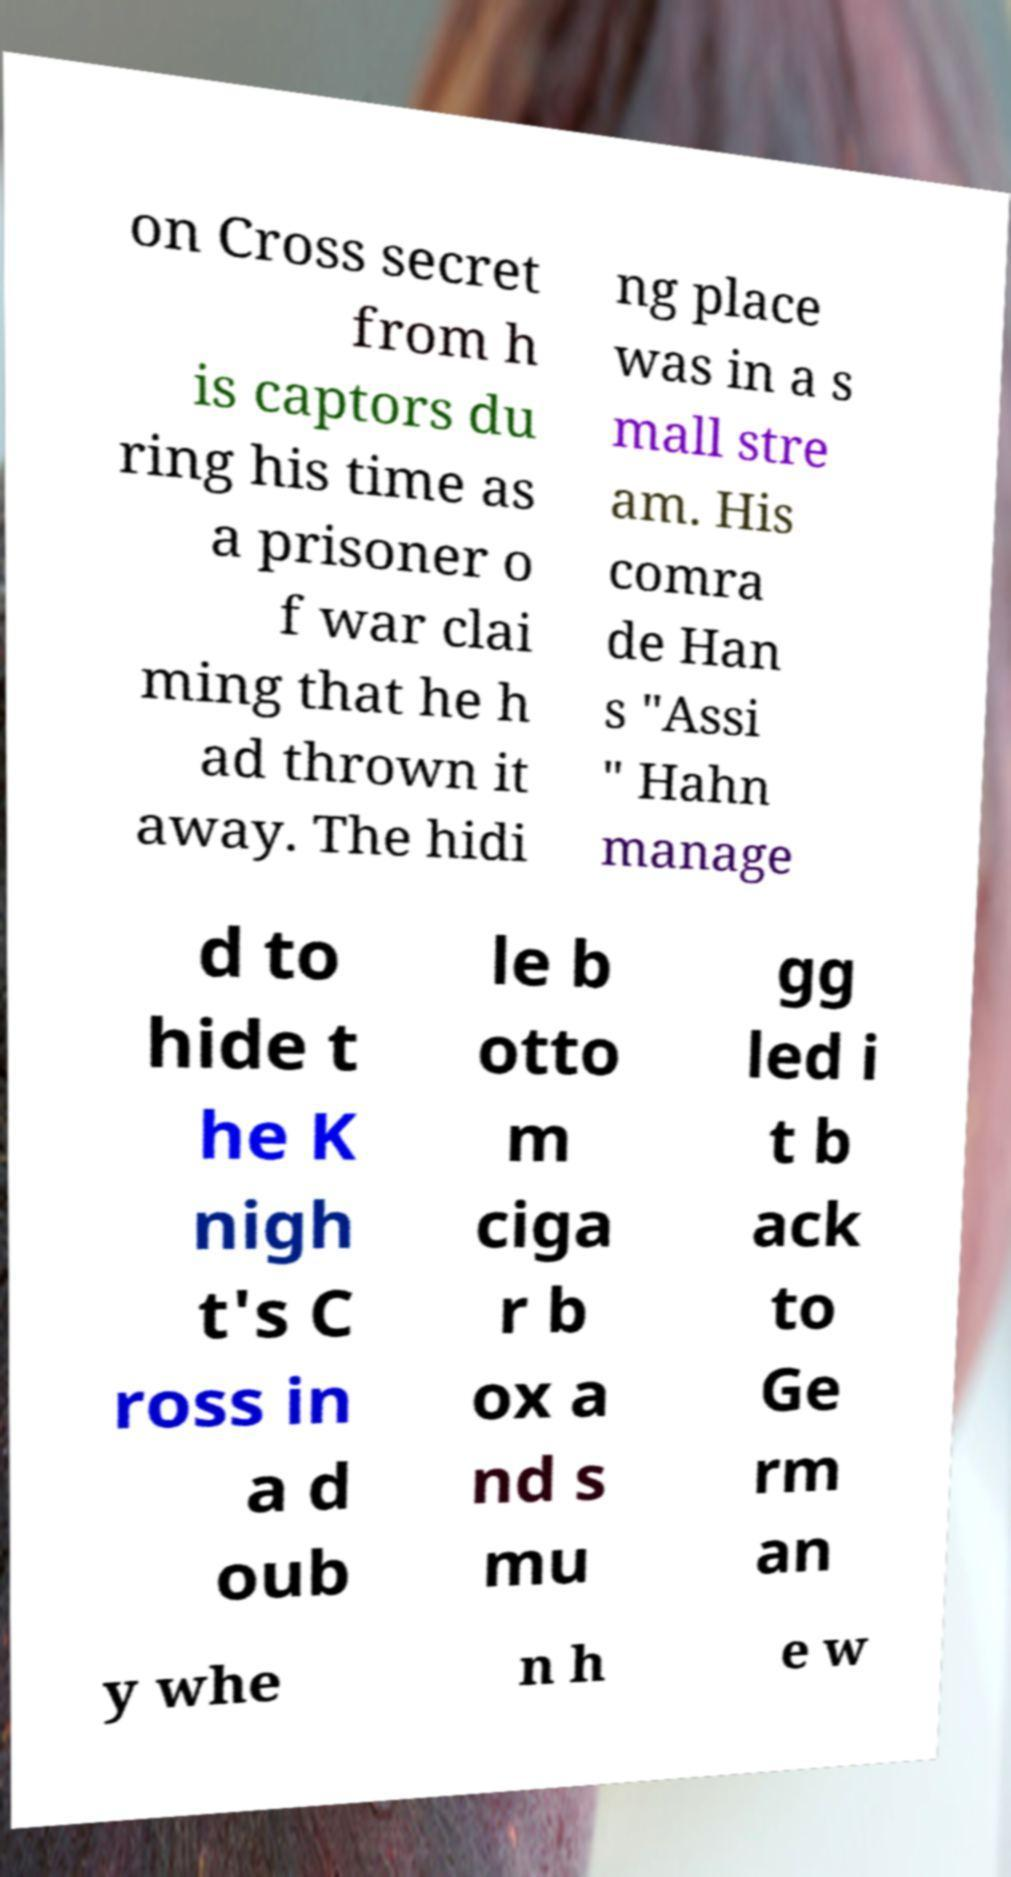I need the written content from this picture converted into text. Can you do that? on Cross secret from h is captors du ring his time as a prisoner o f war clai ming that he h ad thrown it away. The hidi ng place was in a s mall stre am. His comra de Han s "Assi " Hahn manage d to hide t he K nigh t's C ross in a d oub le b otto m ciga r b ox a nd s mu gg led i t b ack to Ge rm an y whe n h e w 